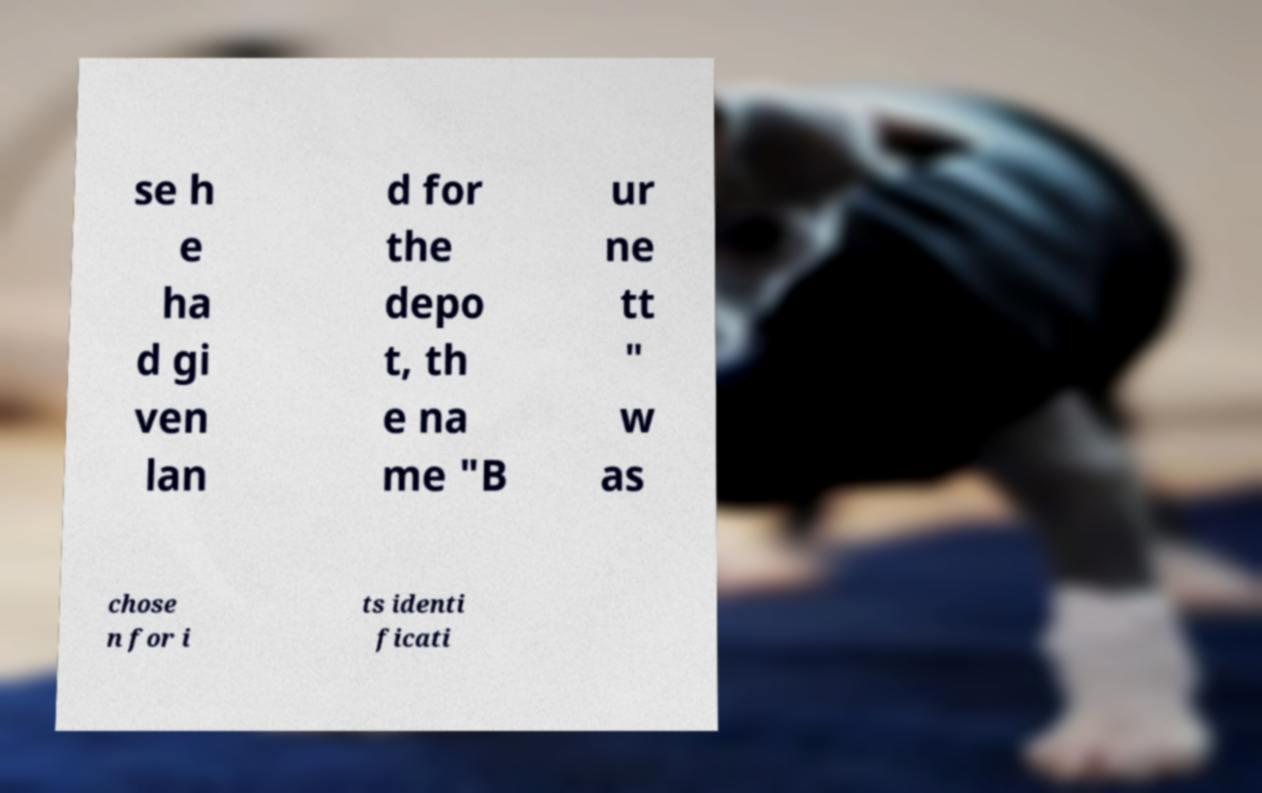Please identify and transcribe the text found in this image. se h e ha d gi ven lan d for the depo t, th e na me "B ur ne tt " w as chose n for i ts identi ficati 